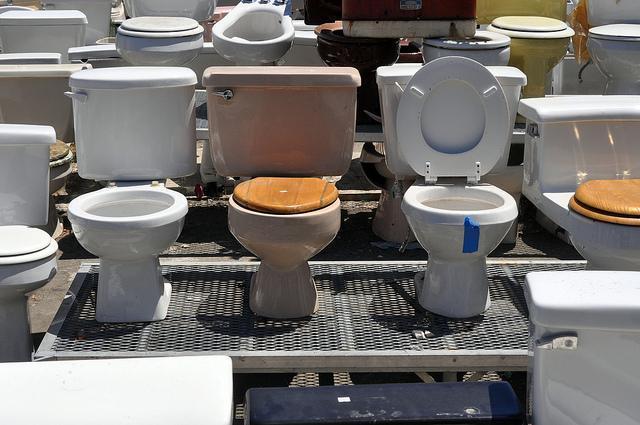How many toilets can you see?
Give a very brief answer. 12. 